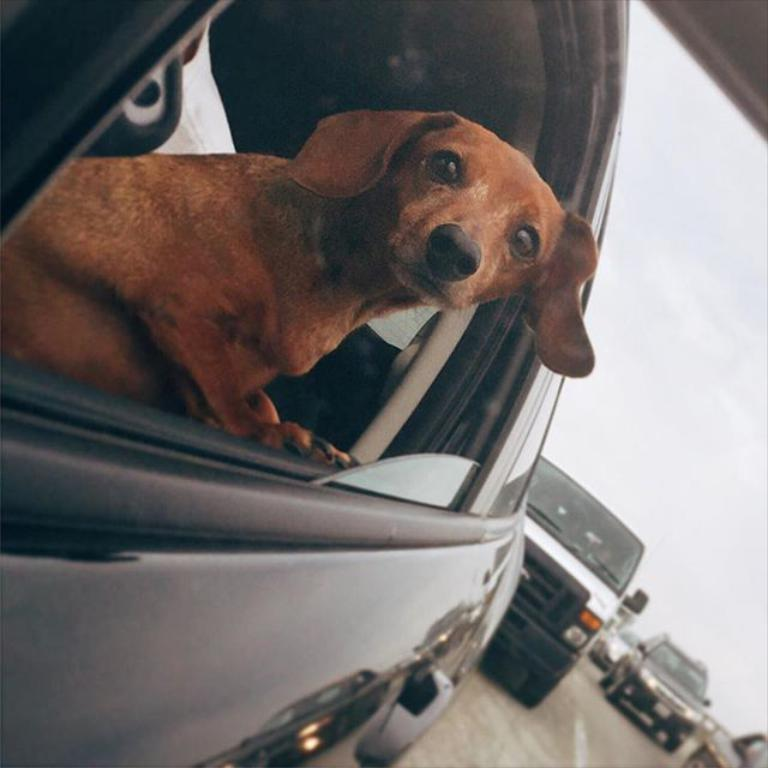What animal can be seen inside the car in the image? There is a dog inside a car in the image. What else can be seen in the background of the image? There are other cars visible on the road in the background of the image. What type of wren can be seen flying near the car in the image? There is no wren present in the image; it only features a dog inside a car and other cars on the road in the background. 